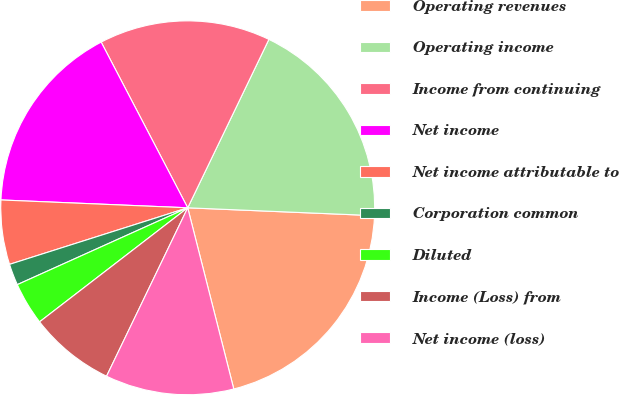<chart> <loc_0><loc_0><loc_500><loc_500><pie_chart><fcel>Operating revenues<fcel>Operating income<fcel>Income from continuing<fcel>Net income<fcel>Net income attributable to<fcel>Corporation common<fcel>Diluted<fcel>Income (Loss) from<fcel>Net income (loss)<nl><fcel>20.37%<fcel>18.52%<fcel>14.81%<fcel>16.67%<fcel>5.56%<fcel>1.85%<fcel>3.7%<fcel>7.41%<fcel>11.11%<nl></chart> 